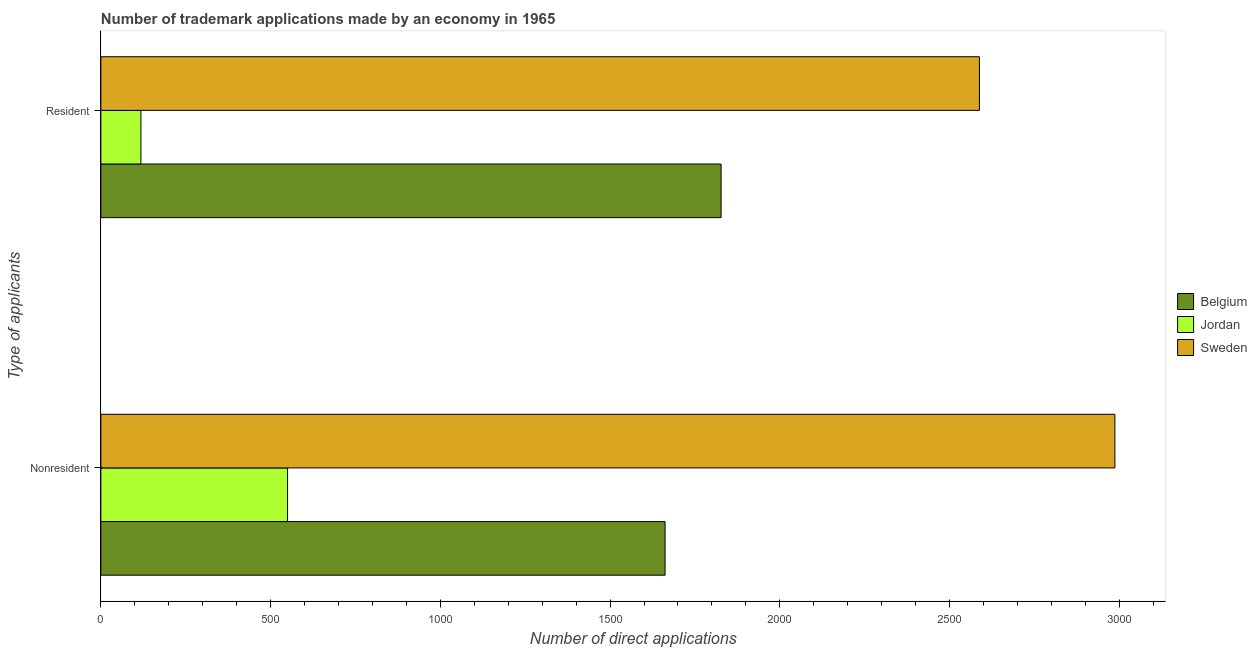How many different coloured bars are there?
Offer a terse response. 3. Are the number of bars per tick equal to the number of legend labels?
Your answer should be compact. Yes. Are the number of bars on each tick of the Y-axis equal?
Give a very brief answer. Yes. What is the label of the 2nd group of bars from the top?
Provide a short and direct response. Nonresident. What is the number of trademark applications made by non residents in Sweden?
Offer a terse response. 2987. Across all countries, what is the maximum number of trademark applications made by residents?
Your answer should be very brief. 2588. Across all countries, what is the minimum number of trademark applications made by residents?
Your response must be concise. 118. In which country was the number of trademark applications made by residents minimum?
Your answer should be compact. Jordan. What is the total number of trademark applications made by residents in the graph?
Your response must be concise. 4533. What is the difference between the number of trademark applications made by residents in Jordan and that in Sweden?
Your answer should be very brief. -2470. What is the difference between the number of trademark applications made by non residents in Jordan and the number of trademark applications made by residents in Belgium?
Your answer should be very brief. -1277. What is the average number of trademark applications made by residents per country?
Provide a short and direct response. 1511. What is the difference between the number of trademark applications made by residents and number of trademark applications made by non residents in Sweden?
Provide a short and direct response. -399. What is the ratio of the number of trademark applications made by non residents in Belgium to that in Jordan?
Provide a succinct answer. 3.02. Is the number of trademark applications made by residents in Sweden less than that in Jordan?
Your answer should be compact. No. In how many countries, is the number of trademark applications made by residents greater than the average number of trademark applications made by residents taken over all countries?
Offer a very short reply. 2. What does the 3rd bar from the bottom in Nonresident represents?
Offer a terse response. Sweden. How many bars are there?
Make the answer very short. 6. Does the graph contain any zero values?
Keep it short and to the point. No. What is the title of the graph?
Your response must be concise. Number of trademark applications made by an economy in 1965. What is the label or title of the X-axis?
Provide a succinct answer. Number of direct applications. What is the label or title of the Y-axis?
Provide a succinct answer. Type of applicants. What is the Number of direct applications of Belgium in Nonresident?
Keep it short and to the point. 1662. What is the Number of direct applications of Jordan in Nonresident?
Offer a very short reply. 550. What is the Number of direct applications of Sweden in Nonresident?
Offer a terse response. 2987. What is the Number of direct applications of Belgium in Resident?
Offer a terse response. 1827. What is the Number of direct applications in Jordan in Resident?
Make the answer very short. 118. What is the Number of direct applications in Sweden in Resident?
Make the answer very short. 2588. Across all Type of applicants, what is the maximum Number of direct applications of Belgium?
Provide a succinct answer. 1827. Across all Type of applicants, what is the maximum Number of direct applications in Jordan?
Make the answer very short. 550. Across all Type of applicants, what is the maximum Number of direct applications in Sweden?
Ensure brevity in your answer.  2987. Across all Type of applicants, what is the minimum Number of direct applications in Belgium?
Your response must be concise. 1662. Across all Type of applicants, what is the minimum Number of direct applications of Jordan?
Your response must be concise. 118. Across all Type of applicants, what is the minimum Number of direct applications of Sweden?
Make the answer very short. 2588. What is the total Number of direct applications of Belgium in the graph?
Ensure brevity in your answer.  3489. What is the total Number of direct applications in Jordan in the graph?
Your answer should be compact. 668. What is the total Number of direct applications of Sweden in the graph?
Provide a short and direct response. 5575. What is the difference between the Number of direct applications of Belgium in Nonresident and that in Resident?
Your answer should be compact. -165. What is the difference between the Number of direct applications in Jordan in Nonresident and that in Resident?
Provide a succinct answer. 432. What is the difference between the Number of direct applications in Sweden in Nonresident and that in Resident?
Your response must be concise. 399. What is the difference between the Number of direct applications in Belgium in Nonresident and the Number of direct applications in Jordan in Resident?
Provide a short and direct response. 1544. What is the difference between the Number of direct applications in Belgium in Nonresident and the Number of direct applications in Sweden in Resident?
Offer a terse response. -926. What is the difference between the Number of direct applications in Jordan in Nonresident and the Number of direct applications in Sweden in Resident?
Offer a very short reply. -2038. What is the average Number of direct applications of Belgium per Type of applicants?
Your response must be concise. 1744.5. What is the average Number of direct applications of Jordan per Type of applicants?
Your response must be concise. 334. What is the average Number of direct applications in Sweden per Type of applicants?
Give a very brief answer. 2787.5. What is the difference between the Number of direct applications of Belgium and Number of direct applications of Jordan in Nonresident?
Provide a short and direct response. 1112. What is the difference between the Number of direct applications in Belgium and Number of direct applications in Sweden in Nonresident?
Ensure brevity in your answer.  -1325. What is the difference between the Number of direct applications of Jordan and Number of direct applications of Sweden in Nonresident?
Your answer should be compact. -2437. What is the difference between the Number of direct applications of Belgium and Number of direct applications of Jordan in Resident?
Provide a succinct answer. 1709. What is the difference between the Number of direct applications of Belgium and Number of direct applications of Sweden in Resident?
Provide a short and direct response. -761. What is the difference between the Number of direct applications of Jordan and Number of direct applications of Sweden in Resident?
Give a very brief answer. -2470. What is the ratio of the Number of direct applications in Belgium in Nonresident to that in Resident?
Your answer should be compact. 0.91. What is the ratio of the Number of direct applications of Jordan in Nonresident to that in Resident?
Provide a short and direct response. 4.66. What is the ratio of the Number of direct applications in Sweden in Nonresident to that in Resident?
Provide a short and direct response. 1.15. What is the difference between the highest and the second highest Number of direct applications in Belgium?
Provide a short and direct response. 165. What is the difference between the highest and the second highest Number of direct applications of Jordan?
Your answer should be compact. 432. What is the difference between the highest and the second highest Number of direct applications of Sweden?
Keep it short and to the point. 399. What is the difference between the highest and the lowest Number of direct applications of Belgium?
Provide a succinct answer. 165. What is the difference between the highest and the lowest Number of direct applications of Jordan?
Provide a succinct answer. 432. What is the difference between the highest and the lowest Number of direct applications in Sweden?
Your answer should be very brief. 399. 